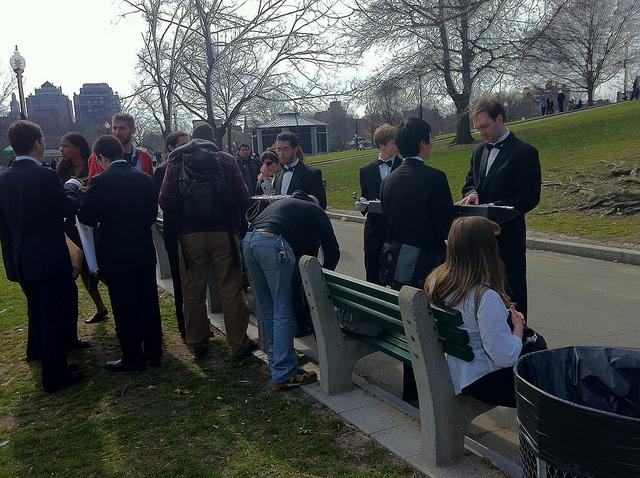What does the man farthest to the right have on his neck? bowtie 